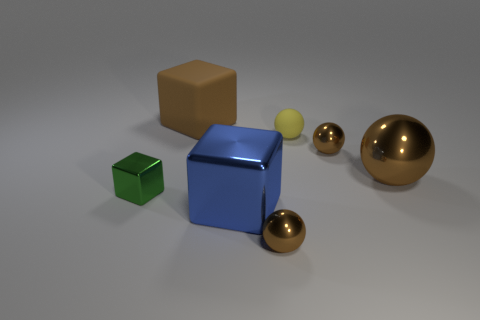Subtract all brown spheres. How many spheres are left? 1 Add 2 big brown rubber spheres. How many objects exist? 9 Subtract all brown blocks. How many blocks are left? 2 Subtract all cyan blocks. How many brown balls are left? 3 Subtract all balls. How many objects are left? 3 Subtract 2 balls. How many balls are left? 2 Subtract all red balls. Subtract all yellow cylinders. How many balls are left? 4 Subtract all big blue shiny things. Subtract all brown balls. How many objects are left? 3 Add 7 small metal spheres. How many small metal spheres are left? 9 Add 5 brown metallic things. How many brown metallic things exist? 8 